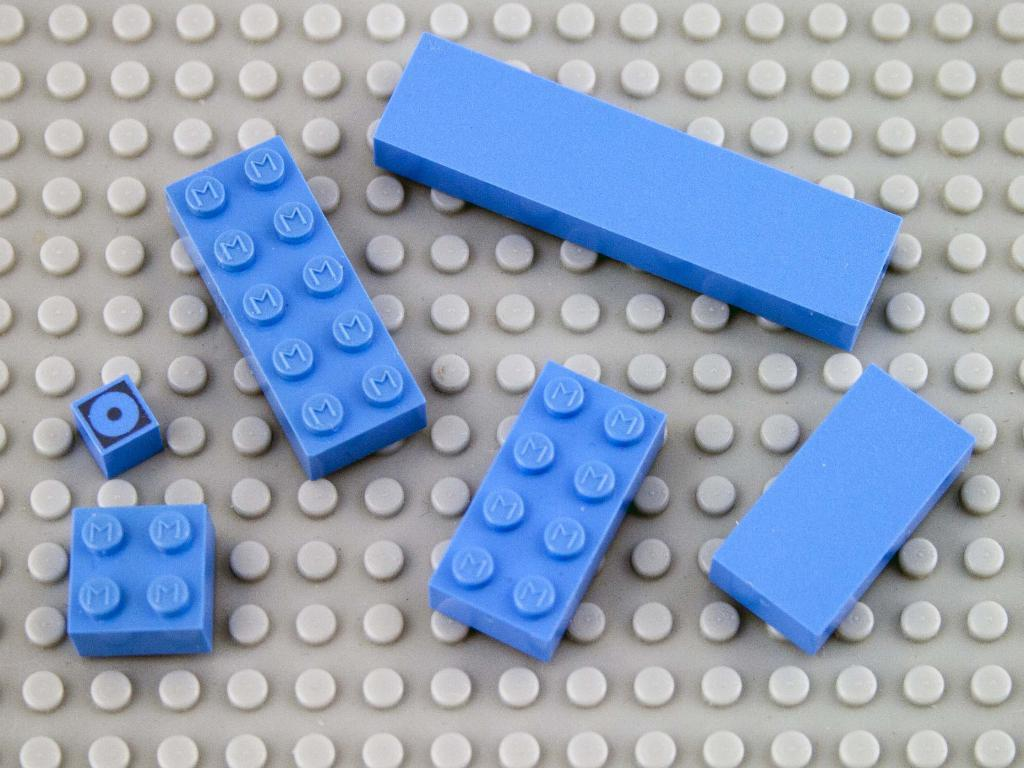What color are the building blocks in the image? The building blocks in the image are blue. How many pigs are sitting on the building blocks in the image? There are no pigs present in the image; it only features blue colored building blocks. What type of shade is provided by the building blocks in the image? The image does not show any shade being provided by the building blocks, as they are not covering or blocking any light source. 